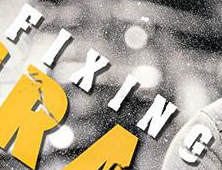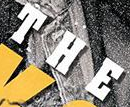What text is displayed in these images sequentially, separated by a semicolon? FIXING; THE 